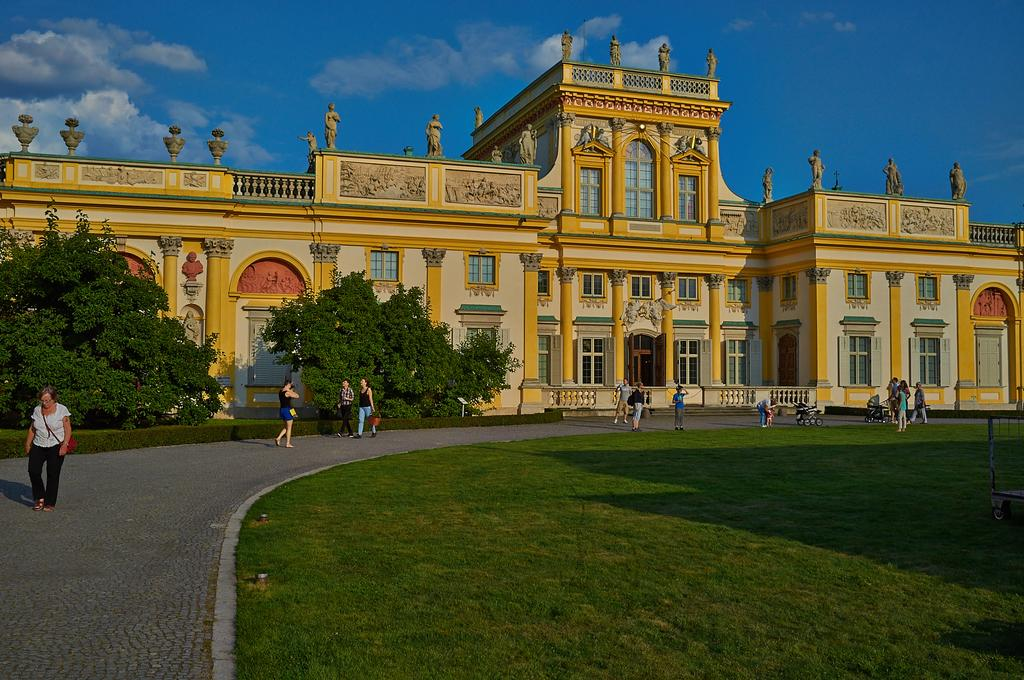What type of structures can be seen in the image? There are buildings in the image. What architectural features can be observed on the buildings? Windows are visible on the buildings. What type of vegetation is present in the image? There are trees and grass in the image. What are the people in the image doing? There are people walking in the image. What mode of transportation is present in the image? Trolleys are in the image. What part of the natural environment is visible in the image? The sky is visible in the image. What type of care is being provided to the zinc in the image? There is no zinc present in the image, so no care is being provided. What is the ground made of in the image? The ground is not explicitly mentioned in the provided facts, so we cannot definitively answer this question. 